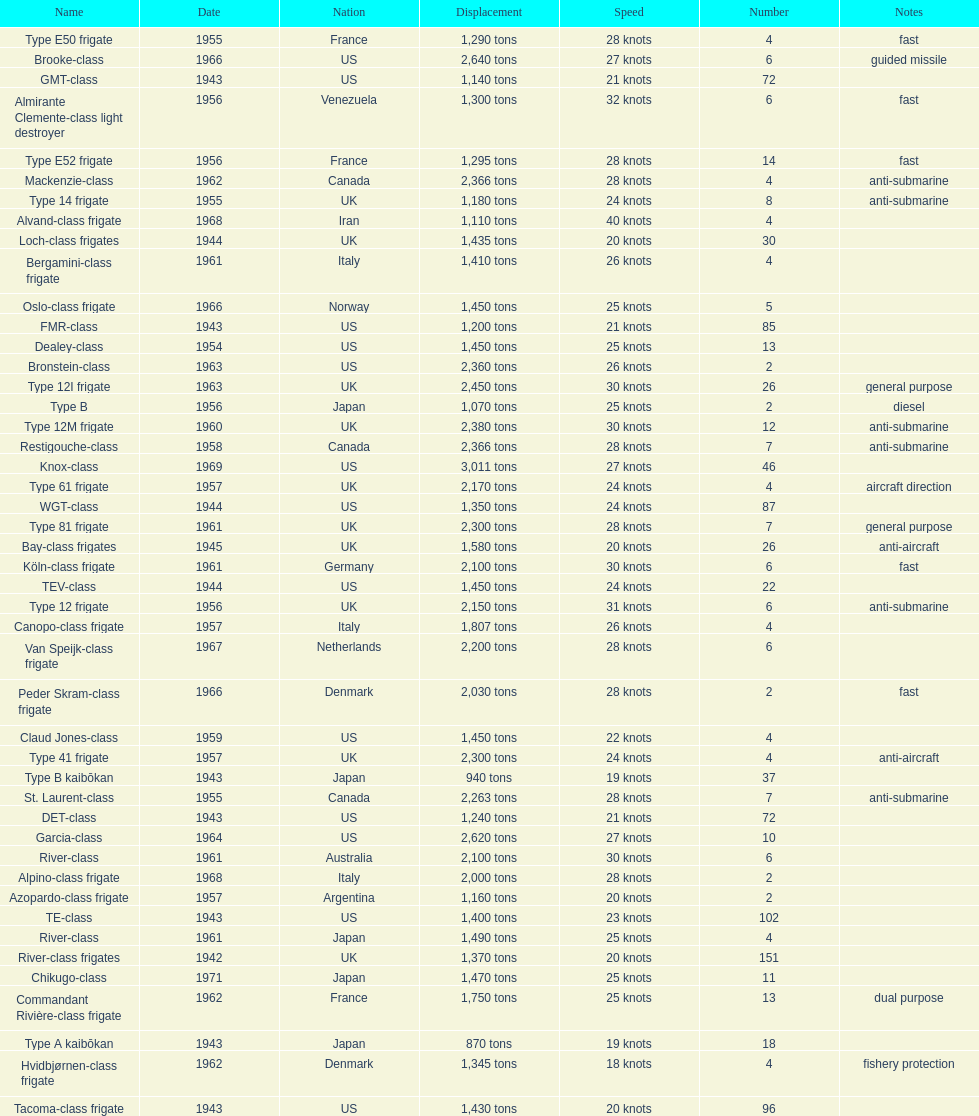What is the top speed? 40 knots. 